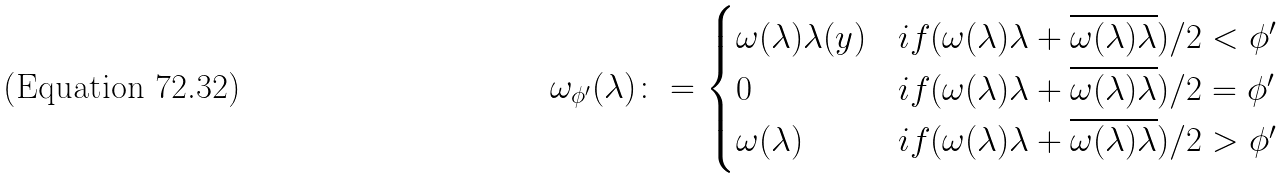<formula> <loc_0><loc_0><loc_500><loc_500>\omega _ { \phi ^ { \prime } } ( \lambda ) \colon = \begin{cases} \omega ( \lambda ) \lambda ( y ) & i f ( \omega ( \lambda ) \lambda + \overline { \omega ( \lambda ) \lambda } ) / 2 < \phi ^ { \prime } \\ 0 & i f ( \omega ( \lambda ) \lambda + \overline { \omega ( \lambda ) \lambda } ) / 2 = \phi ^ { \prime } \\ \omega ( \lambda ) & i f ( \omega ( \lambda ) \lambda + \overline { \omega ( \lambda ) \lambda } ) / 2 > \phi ^ { \prime } \end{cases}</formula> 